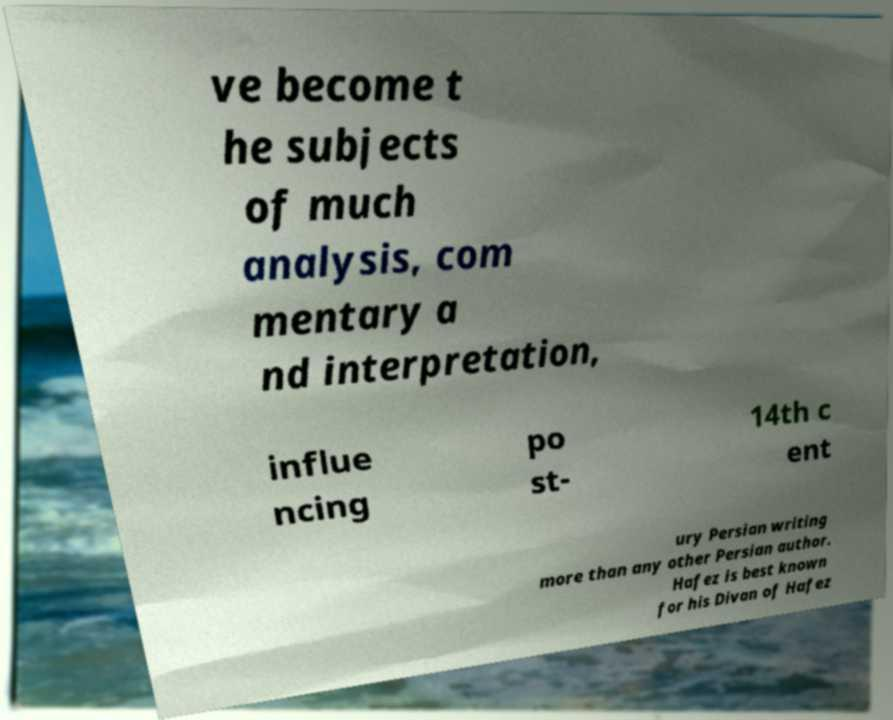Please read and relay the text visible in this image. What does it say? ve become t he subjects of much analysis, com mentary a nd interpretation, influe ncing po st- 14th c ent ury Persian writing more than any other Persian author. Hafez is best known for his Divan of Hafez 